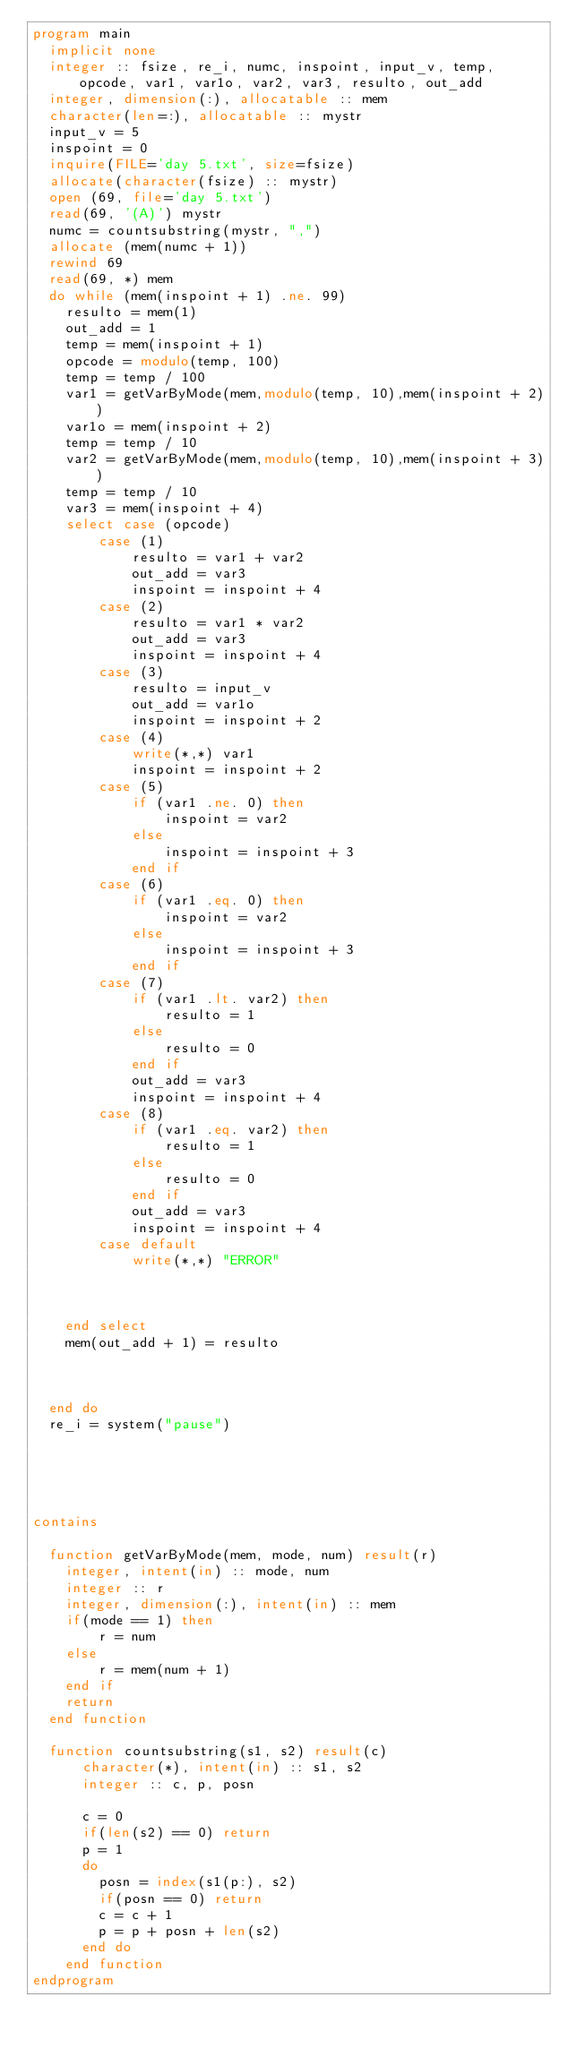<code> <loc_0><loc_0><loc_500><loc_500><_FORTRAN_>program main
  implicit none
  integer :: fsize, re_i, numc, inspoint, input_v, temp, opcode, var1, var1o, var2, var3, resulto, out_add
  integer, dimension(:), allocatable :: mem
  character(len=:), allocatable :: mystr
  input_v = 5
  inspoint = 0
  inquire(FILE='day 5.txt', size=fsize)
  allocate(character(fsize) :: mystr)
  open (69, file='day 5.txt')
  read(69, '(A)') mystr
  numc = countsubstring(mystr, ",")
  allocate (mem(numc + 1))
  rewind 69
  read(69, *) mem
  do while (mem(inspoint + 1) .ne. 99)
    resulto = mem(1)
    out_add = 1
    temp = mem(inspoint + 1)
    opcode = modulo(temp, 100)
    temp = temp / 100
    var1 = getVarByMode(mem,modulo(temp, 10),mem(inspoint + 2))
    var1o = mem(inspoint + 2)
    temp = temp / 10
    var2 = getVarByMode(mem,modulo(temp, 10),mem(inspoint + 3))
    temp = temp / 10
    var3 = mem(inspoint + 4)
    select case (opcode)
        case (1)
            resulto = var1 + var2
            out_add = var3
            inspoint = inspoint + 4
        case (2)
            resulto = var1 * var2
            out_add = var3
            inspoint = inspoint + 4
        case (3)
            resulto = input_v
            out_add = var1o
            inspoint = inspoint + 2
        case (4)
            write(*,*) var1
            inspoint = inspoint + 2
        case (5)
            if (var1 .ne. 0) then
                inspoint = var2
            else
                inspoint = inspoint + 3
            end if
        case (6)
            if (var1 .eq. 0) then
                inspoint = var2
            else
                inspoint = inspoint + 3
            end if
        case (7)
            if (var1 .lt. var2) then
                resulto = 1
            else
                resulto = 0
            end if
            out_add = var3
            inspoint = inspoint + 4
        case (8)
            if (var1 .eq. var2) then
                resulto = 1
            else
                resulto = 0
            end if
            out_add = var3
            inspoint = inspoint + 4
        case default
            write(*,*) "ERROR"



    end select
    mem(out_add + 1) = resulto



  end do
  re_i = system("pause")





contains

  function getVarByMode(mem, mode, num) result(r)
    integer, intent(in) :: mode, num
    integer :: r
    integer, dimension(:), intent(in) :: mem
    if(mode == 1) then
        r = num
    else
        r = mem(num + 1)
    end if
    return
  end function

  function countsubstring(s1, s2) result(c)
      character(*), intent(in) :: s1, s2
      integer :: c, p, posn

      c = 0
      if(len(s2) == 0) return
      p = 1
      do
        posn = index(s1(p:), s2)
        if(posn == 0) return
        c = c + 1
        p = p + posn + len(s2)
      end do
    end function
endprogram
</code> 